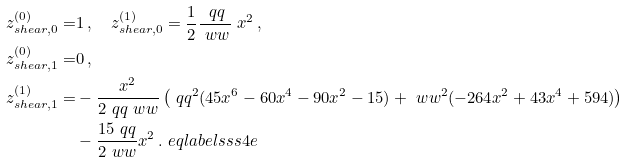<formula> <loc_0><loc_0><loc_500><loc_500>z _ { s h e a r , 0 } ^ { ( 0 ) } = & 1 \, , \quad z _ { s h e a r , 0 } ^ { ( 1 ) } = \frac { 1 } { 2 } \frac { \ q q } { \ w w } \ x ^ { 2 } \, , \\ z _ { s h e a r , 1 } ^ { ( 0 ) } = & 0 \, , \\ z _ { s h e a r , 1 } ^ { ( 1 ) } = & - \frac { x ^ { 2 } } { 2 \ q q \ w w } \left ( \ q q ^ { 2 } ( 4 5 x ^ { 6 } - 6 0 x ^ { 4 } - 9 0 x ^ { 2 } - 1 5 ) + \ w w ^ { 2 } ( - 2 6 4 x ^ { 2 } + 4 3 x ^ { 4 } + 5 9 4 ) \right ) \\ & - \frac { 1 5 \ q q } { 2 \ w w } x ^ { 2 } \, . \ e q l a b e l { s s s 4 e }</formula> 